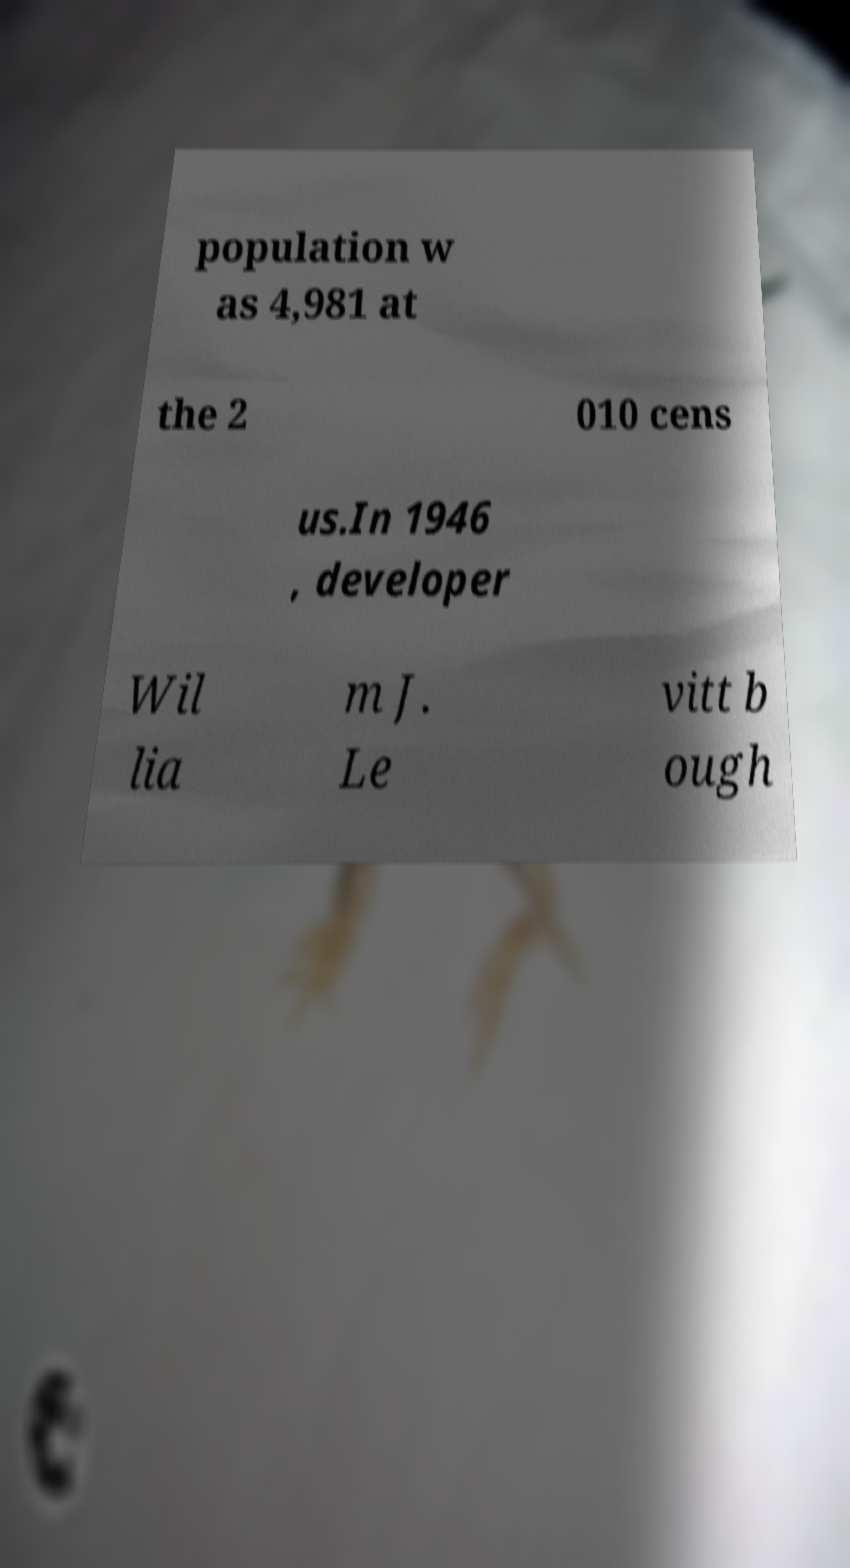Can you read and provide the text displayed in the image?This photo seems to have some interesting text. Can you extract and type it out for me? population w as 4,981 at the 2 010 cens us.In 1946 , developer Wil lia m J. Le vitt b ough 